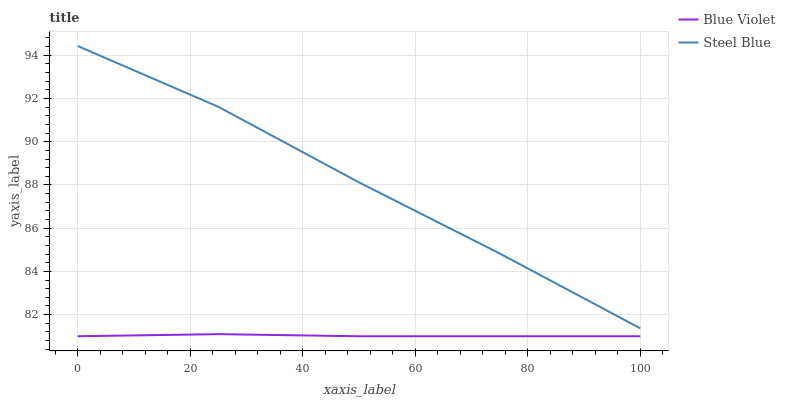Does Blue Violet have the minimum area under the curve?
Answer yes or no. Yes. Does Steel Blue have the maximum area under the curve?
Answer yes or no. Yes. Does Blue Violet have the maximum area under the curve?
Answer yes or no. No. Is Blue Violet the smoothest?
Answer yes or no. Yes. Is Steel Blue the roughest?
Answer yes or no. Yes. Is Blue Violet the roughest?
Answer yes or no. No. Does Blue Violet have the lowest value?
Answer yes or no. Yes. Does Steel Blue have the highest value?
Answer yes or no. Yes. Does Blue Violet have the highest value?
Answer yes or no. No. Is Blue Violet less than Steel Blue?
Answer yes or no. Yes. Is Steel Blue greater than Blue Violet?
Answer yes or no. Yes. Does Blue Violet intersect Steel Blue?
Answer yes or no. No. 